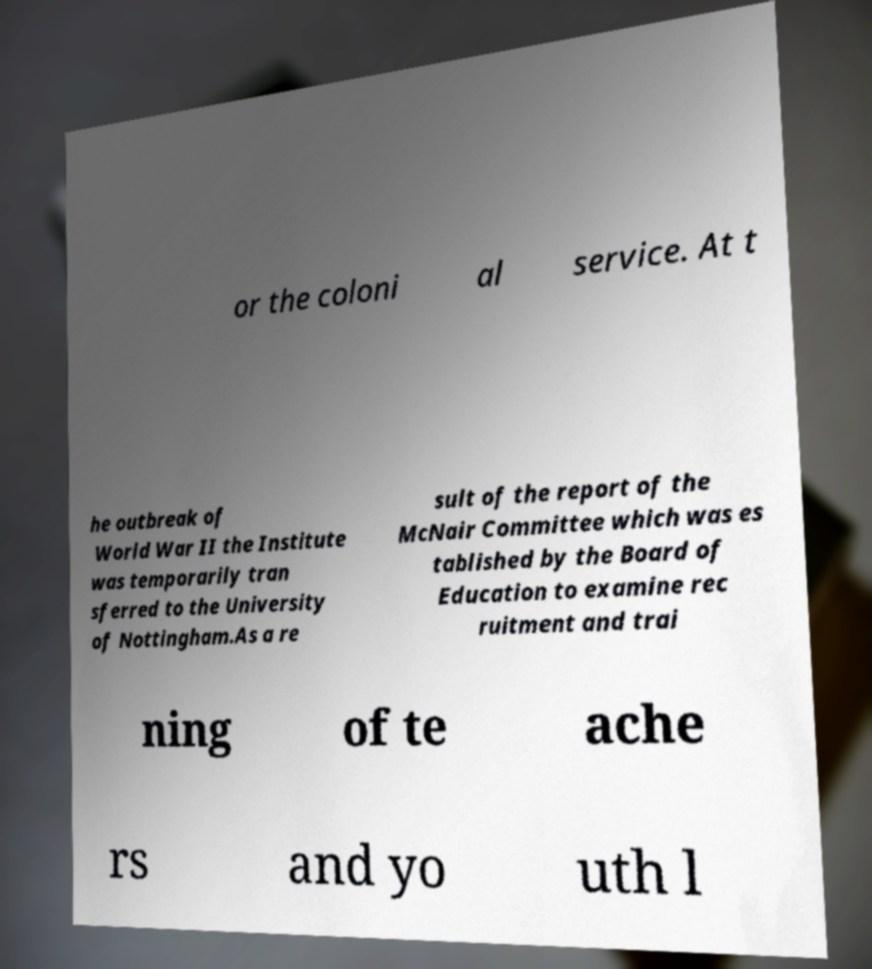Could you extract and type out the text from this image? or the coloni al service. At t he outbreak of World War II the Institute was temporarily tran sferred to the University of Nottingham.As a re sult of the report of the McNair Committee which was es tablished by the Board of Education to examine rec ruitment and trai ning of te ache rs and yo uth l 